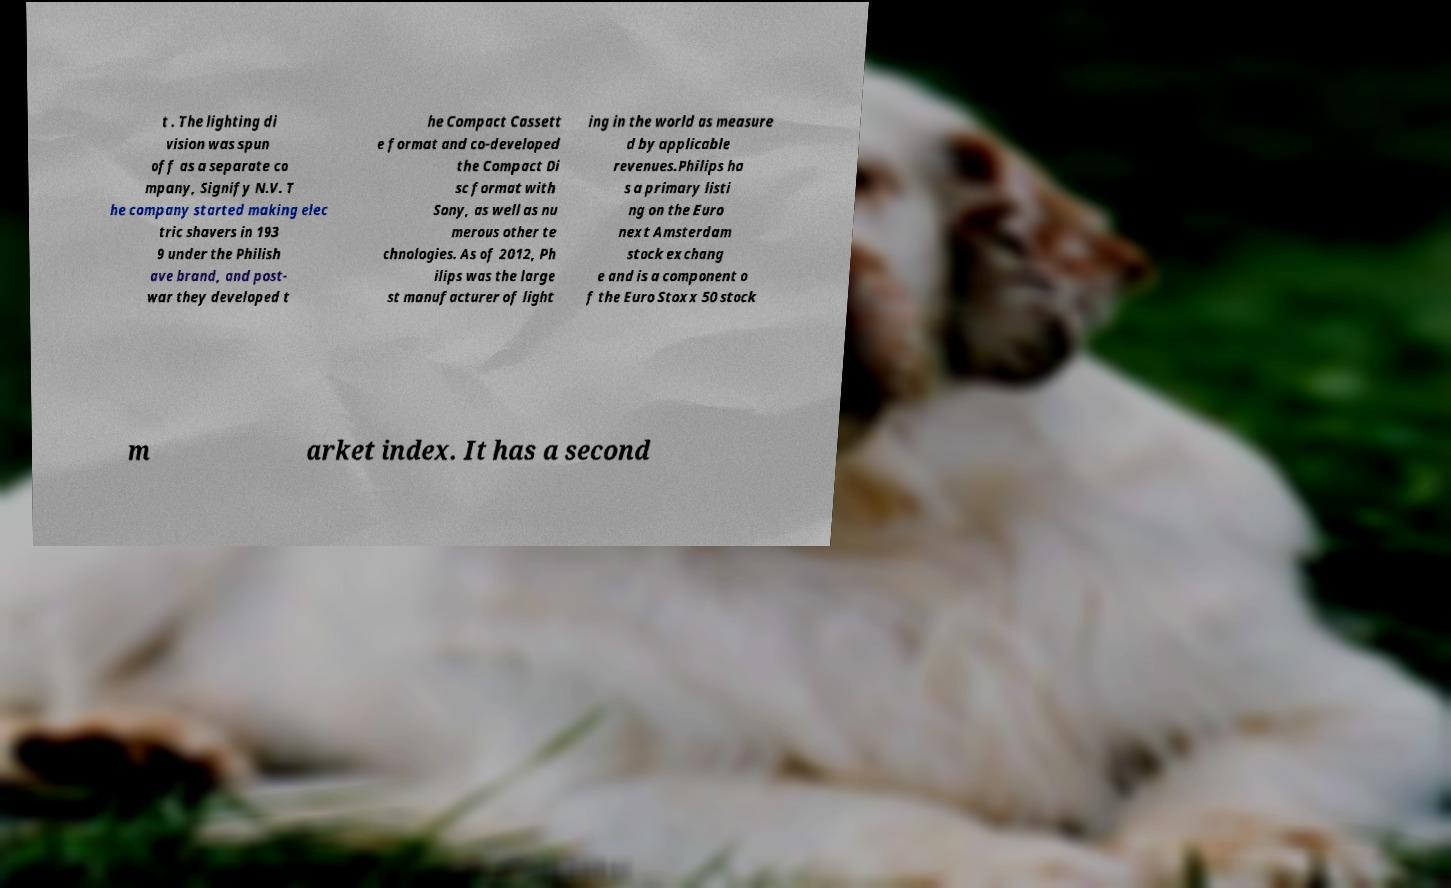There's text embedded in this image that I need extracted. Can you transcribe it verbatim? t . The lighting di vision was spun off as a separate co mpany, Signify N.V. T he company started making elec tric shavers in 193 9 under the Philish ave brand, and post- war they developed t he Compact Cassett e format and co-developed the Compact Di sc format with Sony, as well as nu merous other te chnologies. As of 2012, Ph ilips was the large st manufacturer of light ing in the world as measure d by applicable revenues.Philips ha s a primary listi ng on the Euro next Amsterdam stock exchang e and is a component o f the Euro Stoxx 50 stock m arket index. It has a second 